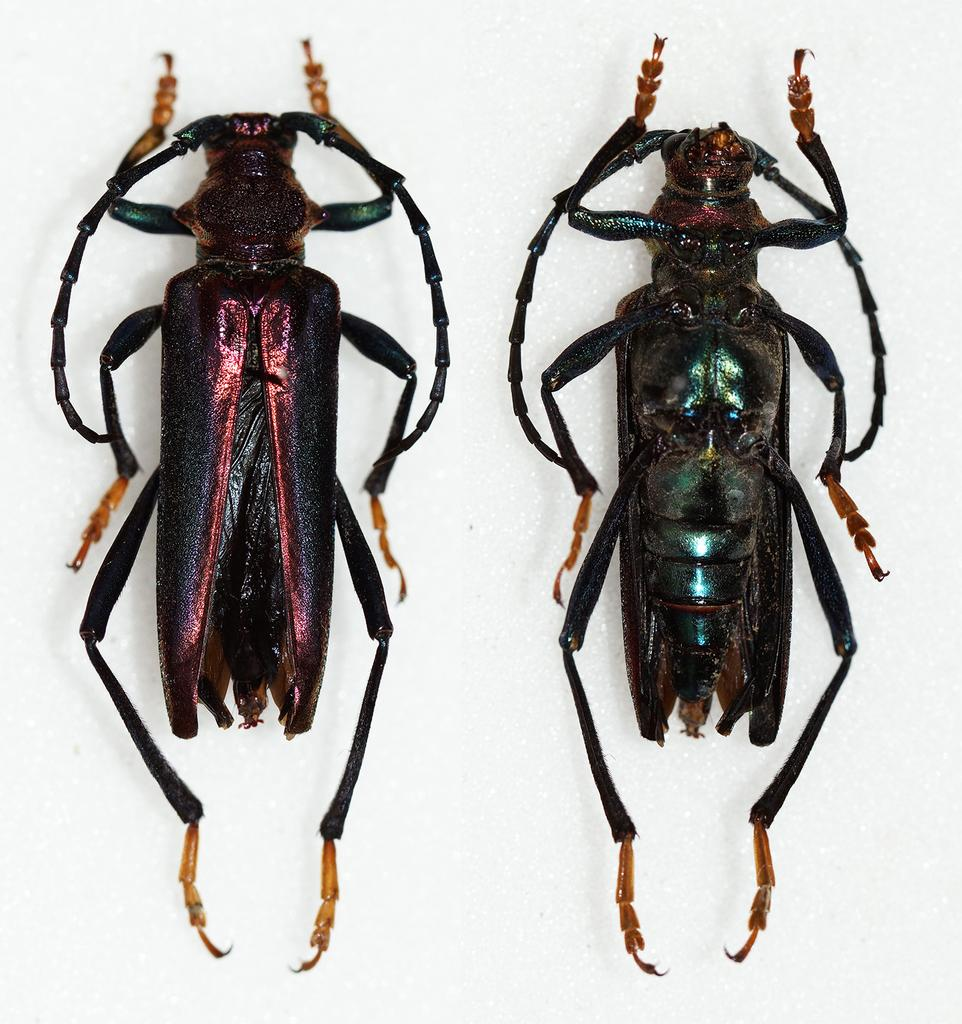How many insects are present in the image? There are two insects in the image. What is the color of the surface on which the insects are located? The insects are on a white color surface. What type of sleet can be seen falling on the donkey in the image? There is no sleet or donkey present in the image; it features two insects on a white surface. 